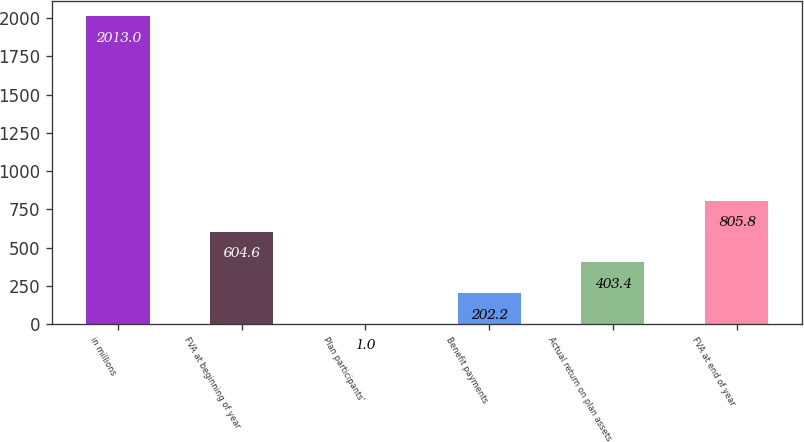Convert chart. <chart><loc_0><loc_0><loc_500><loc_500><bar_chart><fcel>in millions<fcel>FVA at beginning of year<fcel>Plan participants'<fcel>Benefit payments<fcel>Actual return on plan assets<fcel>FVA at end of year<nl><fcel>2013<fcel>604.6<fcel>1<fcel>202.2<fcel>403.4<fcel>805.8<nl></chart> 